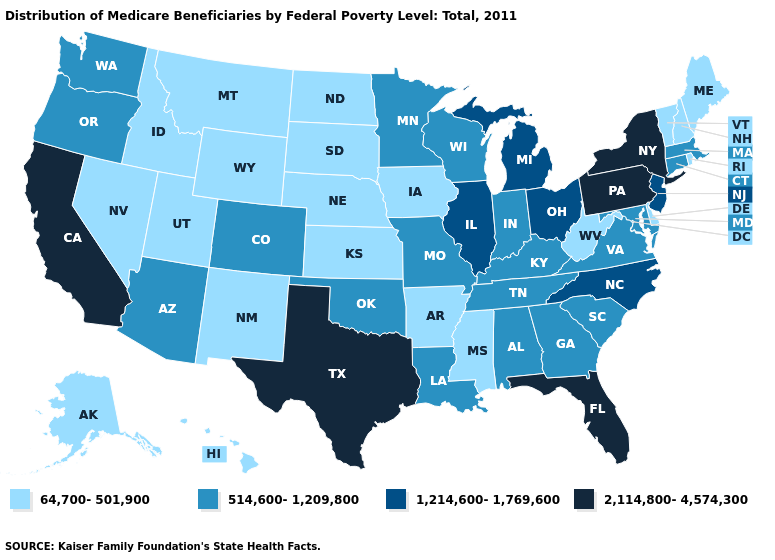Among the states that border Wisconsin , which have the highest value?
Quick response, please. Illinois, Michigan. What is the value of Maine?
Quick response, please. 64,700-501,900. Does the first symbol in the legend represent the smallest category?
Write a very short answer. Yes. What is the highest value in the USA?
Write a very short answer. 2,114,800-4,574,300. Among the states that border New Hampshire , which have the lowest value?
Concise answer only. Maine, Vermont. Among the states that border Kentucky , which have the lowest value?
Keep it brief. West Virginia. What is the highest value in the South ?
Give a very brief answer. 2,114,800-4,574,300. Among the states that border Tennessee , which have the lowest value?
Short answer required. Arkansas, Mississippi. Name the states that have a value in the range 64,700-501,900?
Quick response, please. Alaska, Arkansas, Delaware, Hawaii, Idaho, Iowa, Kansas, Maine, Mississippi, Montana, Nebraska, Nevada, New Hampshire, New Mexico, North Dakota, Rhode Island, South Dakota, Utah, Vermont, West Virginia, Wyoming. Name the states that have a value in the range 514,600-1,209,800?
Answer briefly. Alabama, Arizona, Colorado, Connecticut, Georgia, Indiana, Kentucky, Louisiana, Maryland, Massachusetts, Minnesota, Missouri, Oklahoma, Oregon, South Carolina, Tennessee, Virginia, Washington, Wisconsin. Which states have the lowest value in the USA?
Short answer required. Alaska, Arkansas, Delaware, Hawaii, Idaho, Iowa, Kansas, Maine, Mississippi, Montana, Nebraska, Nevada, New Hampshire, New Mexico, North Dakota, Rhode Island, South Dakota, Utah, Vermont, West Virginia, Wyoming. What is the lowest value in states that border New Jersey?
Short answer required. 64,700-501,900. What is the highest value in the USA?
Quick response, please. 2,114,800-4,574,300. What is the value of New York?
Short answer required. 2,114,800-4,574,300. Does Ohio have the same value as Georgia?
Keep it brief. No. 